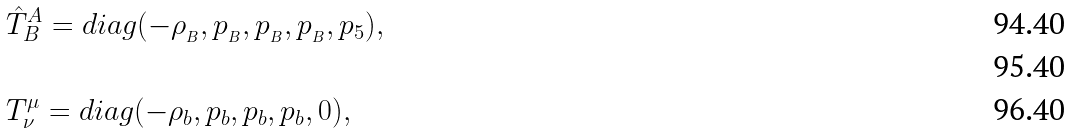<formula> <loc_0><loc_0><loc_500><loc_500>& \hat { T } ^ { A } _ { B } = d i a g ( - \rho _ { _ { B } } , p _ { _ { B } } , p _ { _ { B } } , p _ { _ { B } } , p _ { 5 } ) , \\ \\ & T ^ { \mu } _ { \nu } = d i a g ( - \rho _ { b } , p _ { b } , p _ { b } , p _ { b } , 0 ) ,</formula> 